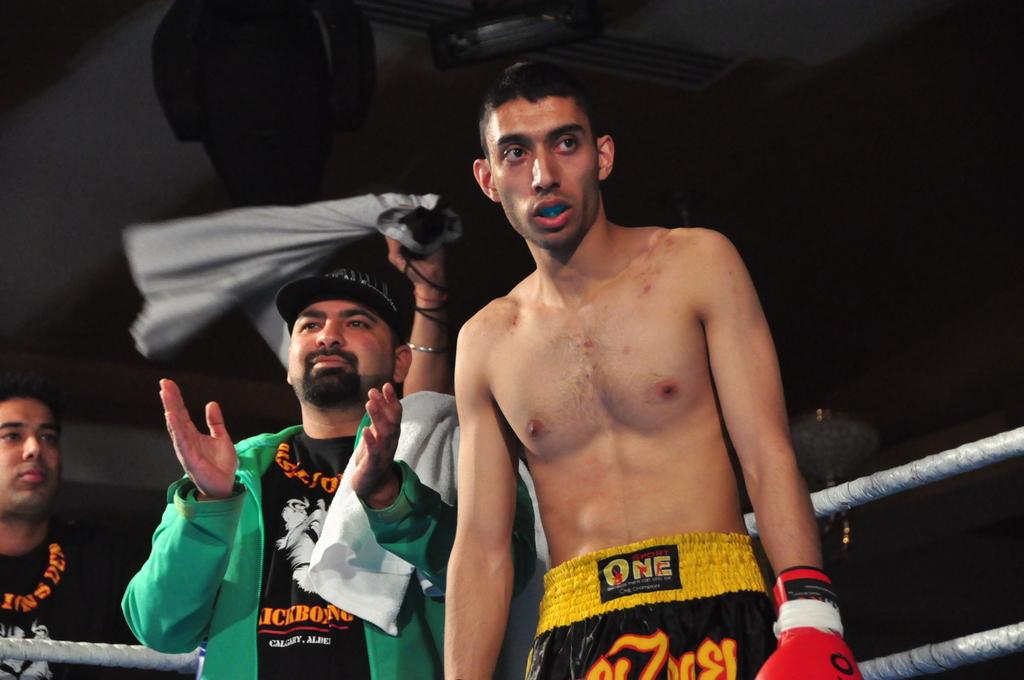<image>
Give a short and clear explanation of the subsequent image. A man in a green jacket, with a towel over his shoulder is clapping as a boxer wearing shorts that say One on the waist stands in front of him. 